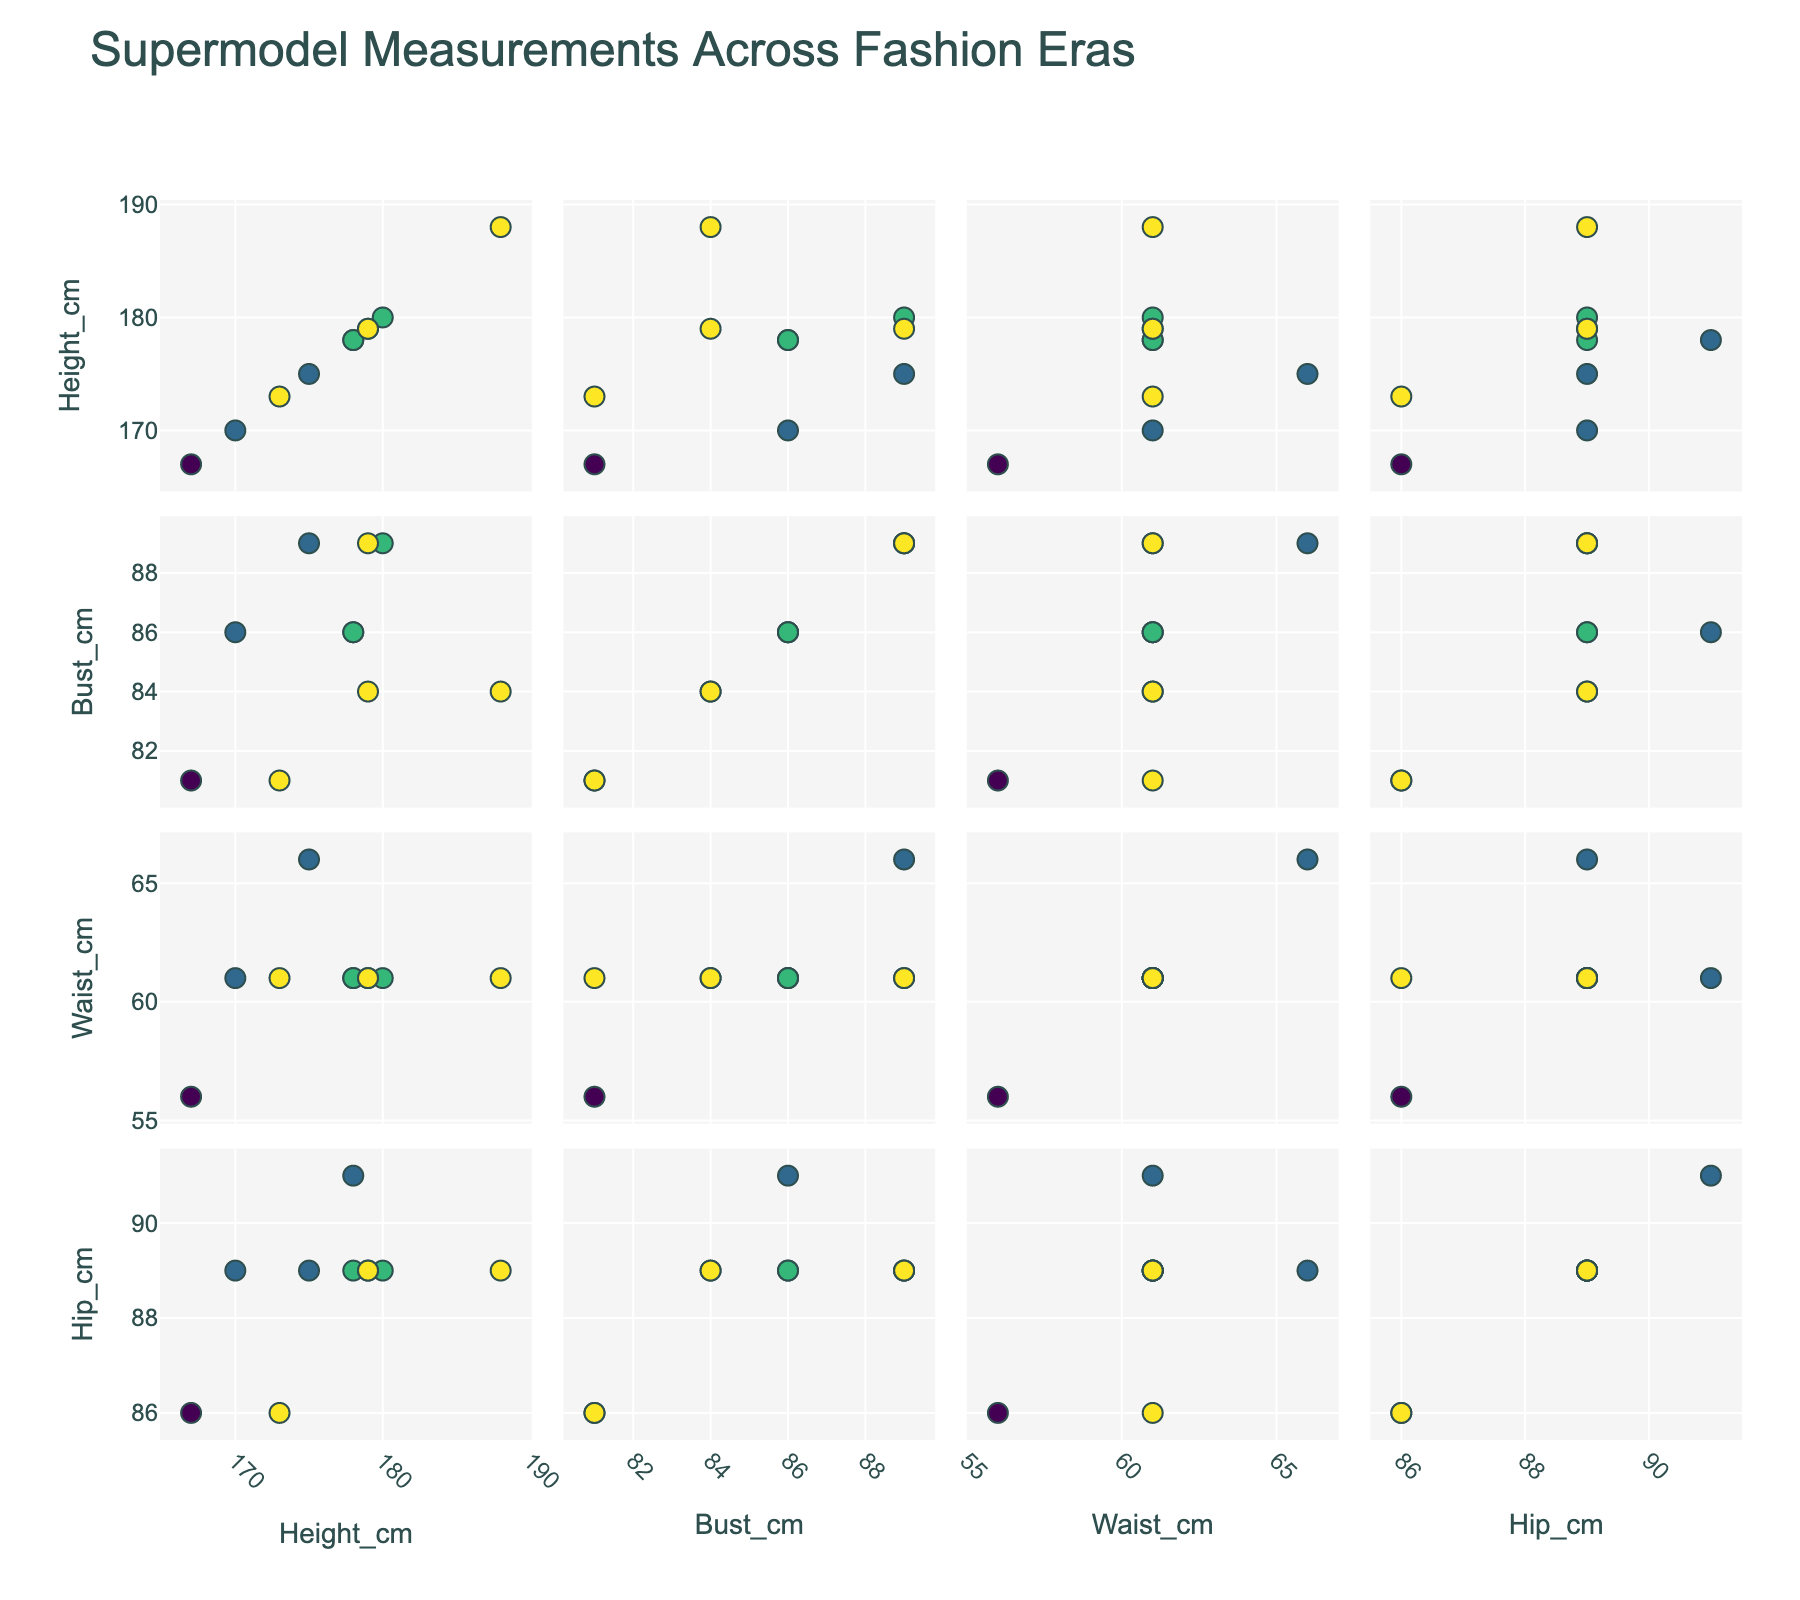What is the title of the plot? The title of the plot is usually located at the top of the figure. By looking at the figure, you can read the title text directly.
Answer: Supermodel Measurements Across Fashion Eras How many unique fashion eras are represented in the plot? The scatterplot matrix uses different colors for each fashion era. By observing the legend, you can count the number of distinct eras listed.
Answer: 4 Which supermodel has the smallest bust measurement? To find the supermodel with the smallest bust, locate the scatter plot for the 'Bust_cm' column, and check the lowest y-value. Hover over that point to see the model's name.
Answer: Twiggy Which era does Karlie Kloss belong to, and what are her Hip measurements? Locate the supermodel Karlie Kloss by hovering over the points in the plot or checking the legend colors. Then look at the points where her name appears, particularly in the hip measurement subplot.
Answer: 2010s, 89 cm What is the average height of supermodels from the 1990s? Identify the supermodels from the 1990s by their color, and then find their height values in the relevant scatter plots. Sum these values and divide by the number of 1990s supermodels.
Answer: (178 + 175 + 170) / 3 = 174.33 cm Among Twiggy, Naomi Campbell, and Gigi Hadid, who has the largest hip measurement? Compare the hip measurements for Twiggy, Naomi Campbell, and Gigi Hadid by looking at the subplot for hip measurements and hovering over the relevant points.
Answer: Naomi Campbell and Gigi Hadid (tie with 89 cm) Is there a trend in waist measurements over the different eras? Observe the 'Waist_cm' column in the scatterplot matrix and look at the spread of data points across different eras. Consider if there is a noticeable pattern or trend in the waist measurements.
Answer: Yes, most have a similar waist measurement (~61 cm) across eras How does the height of supermodels in the 2010s compare to those in the 2000s? Compare the height measurements of supermodels from the 2010s to those from the 2000s by looking at the respective points in the height subplots and observing any differences.
Answer: 2010s models are generally taller Which measurement shows the least variation among supermodels? Assess the scatterplots for bust, waist, and hip measurements and compare the spread of data points to determine which has the least variability.
Answer: Waist measurements What is the relationship between bust and waist measurements among supermodels from the 2000s? Look specifically at the scatter plot showing bust versus waist measurements. Focus on the points belonging to the 2000s era and observe any patterns or correlations.
Answer: Positive correlation, usually 86-89 cm bust with ~61 cm waist 